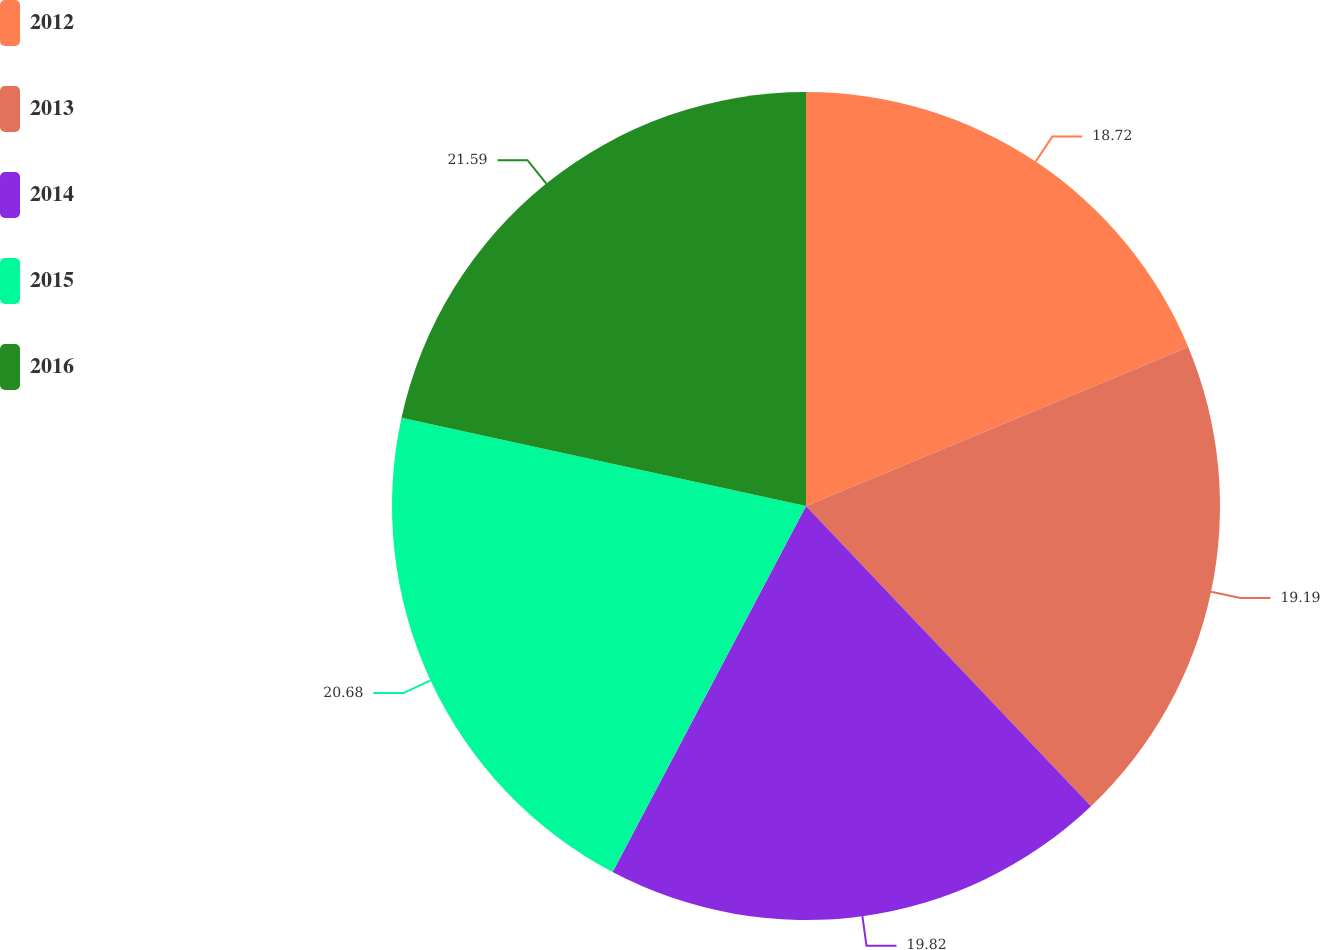<chart> <loc_0><loc_0><loc_500><loc_500><pie_chart><fcel>2012<fcel>2013<fcel>2014<fcel>2015<fcel>2016<nl><fcel>18.72%<fcel>19.19%<fcel>19.82%<fcel>20.68%<fcel>21.58%<nl></chart> 